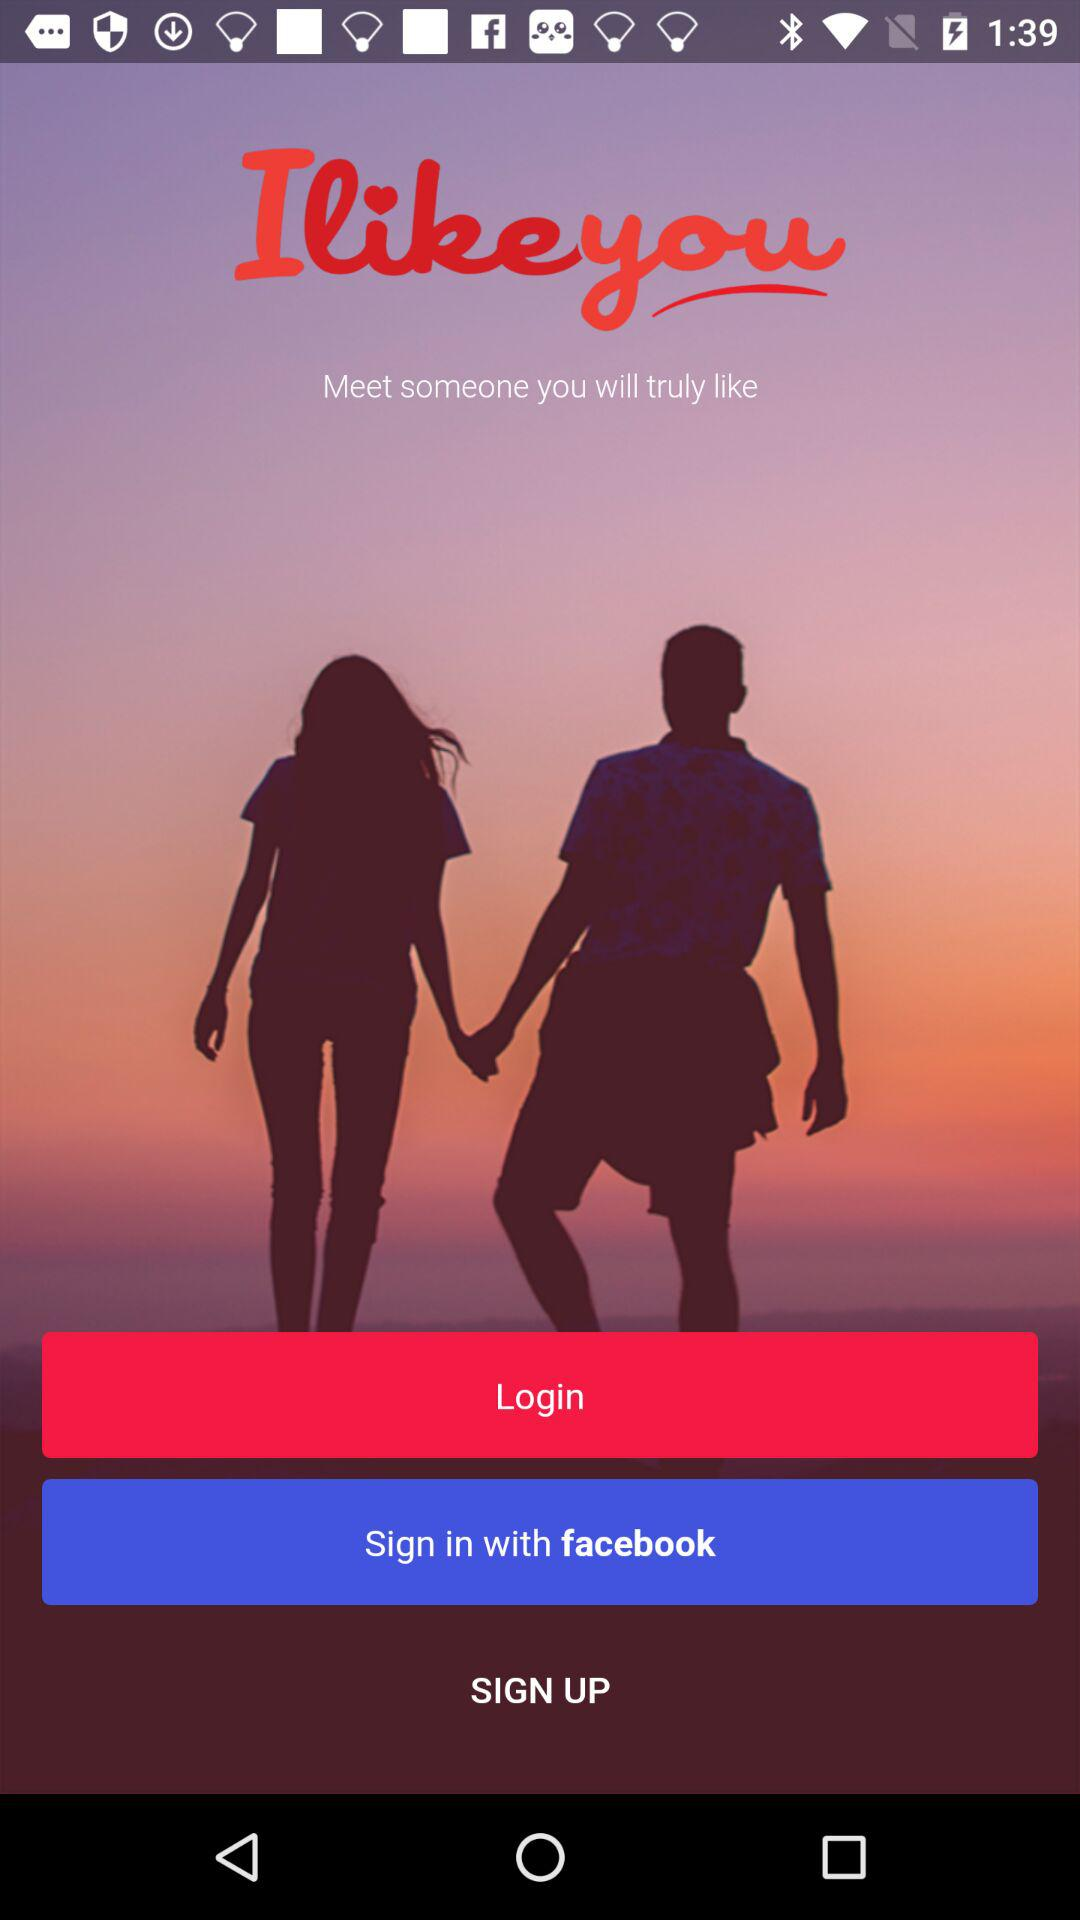What is the name of the application? The name of the application is "Ilikeyou". 